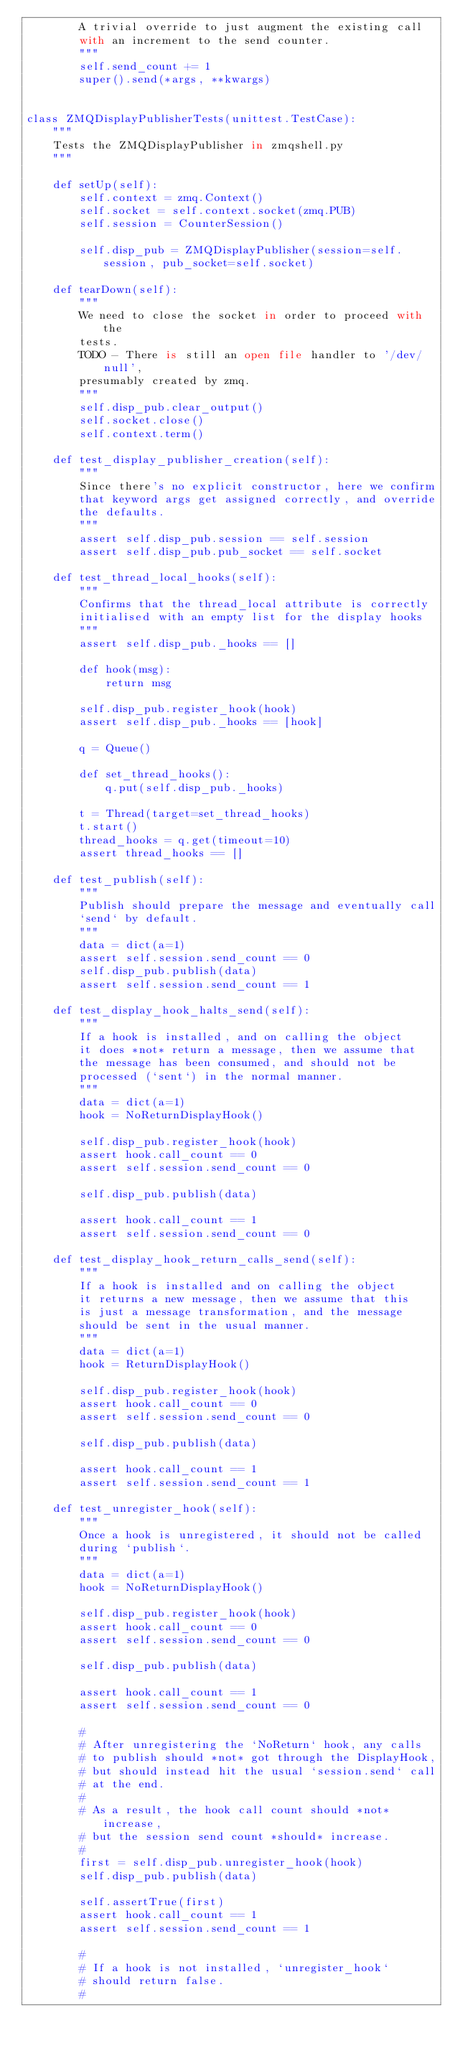<code> <loc_0><loc_0><loc_500><loc_500><_Python_>        A trivial override to just augment the existing call
        with an increment to the send counter.
        """
        self.send_count += 1
        super().send(*args, **kwargs)


class ZMQDisplayPublisherTests(unittest.TestCase):
    """
    Tests the ZMQDisplayPublisher in zmqshell.py
    """

    def setUp(self):
        self.context = zmq.Context()
        self.socket = self.context.socket(zmq.PUB)
        self.session = CounterSession()

        self.disp_pub = ZMQDisplayPublisher(session=self.session, pub_socket=self.socket)

    def tearDown(self):
        """
        We need to close the socket in order to proceed with the
        tests.
        TODO - There is still an open file handler to '/dev/null',
        presumably created by zmq.
        """
        self.disp_pub.clear_output()
        self.socket.close()
        self.context.term()

    def test_display_publisher_creation(self):
        """
        Since there's no explicit constructor, here we confirm
        that keyword args get assigned correctly, and override
        the defaults.
        """
        assert self.disp_pub.session == self.session
        assert self.disp_pub.pub_socket == self.socket

    def test_thread_local_hooks(self):
        """
        Confirms that the thread_local attribute is correctly
        initialised with an empty list for the display hooks
        """
        assert self.disp_pub._hooks == []

        def hook(msg):
            return msg

        self.disp_pub.register_hook(hook)
        assert self.disp_pub._hooks == [hook]

        q = Queue()

        def set_thread_hooks():
            q.put(self.disp_pub._hooks)

        t = Thread(target=set_thread_hooks)
        t.start()
        thread_hooks = q.get(timeout=10)
        assert thread_hooks == []

    def test_publish(self):
        """
        Publish should prepare the message and eventually call
        `send` by default.
        """
        data = dict(a=1)
        assert self.session.send_count == 0
        self.disp_pub.publish(data)
        assert self.session.send_count == 1

    def test_display_hook_halts_send(self):
        """
        If a hook is installed, and on calling the object
        it does *not* return a message, then we assume that
        the message has been consumed, and should not be
        processed (`sent`) in the normal manner.
        """
        data = dict(a=1)
        hook = NoReturnDisplayHook()

        self.disp_pub.register_hook(hook)
        assert hook.call_count == 0
        assert self.session.send_count == 0

        self.disp_pub.publish(data)

        assert hook.call_count == 1
        assert self.session.send_count == 0

    def test_display_hook_return_calls_send(self):
        """
        If a hook is installed and on calling the object
        it returns a new message, then we assume that this
        is just a message transformation, and the message
        should be sent in the usual manner.
        """
        data = dict(a=1)
        hook = ReturnDisplayHook()

        self.disp_pub.register_hook(hook)
        assert hook.call_count == 0
        assert self.session.send_count == 0

        self.disp_pub.publish(data)

        assert hook.call_count == 1
        assert self.session.send_count == 1

    def test_unregister_hook(self):
        """
        Once a hook is unregistered, it should not be called
        during `publish`.
        """
        data = dict(a=1)
        hook = NoReturnDisplayHook()

        self.disp_pub.register_hook(hook)
        assert hook.call_count == 0
        assert self.session.send_count == 0

        self.disp_pub.publish(data)

        assert hook.call_count == 1
        assert self.session.send_count == 0

        #
        # After unregistering the `NoReturn` hook, any calls
        # to publish should *not* got through the DisplayHook,
        # but should instead hit the usual `session.send` call
        # at the end.
        #
        # As a result, the hook call count should *not* increase,
        # but the session send count *should* increase.
        #
        first = self.disp_pub.unregister_hook(hook)
        self.disp_pub.publish(data)

        self.assertTrue(first)
        assert hook.call_count == 1
        assert self.session.send_count == 1

        #
        # If a hook is not installed, `unregister_hook`
        # should return false.
        #</code> 